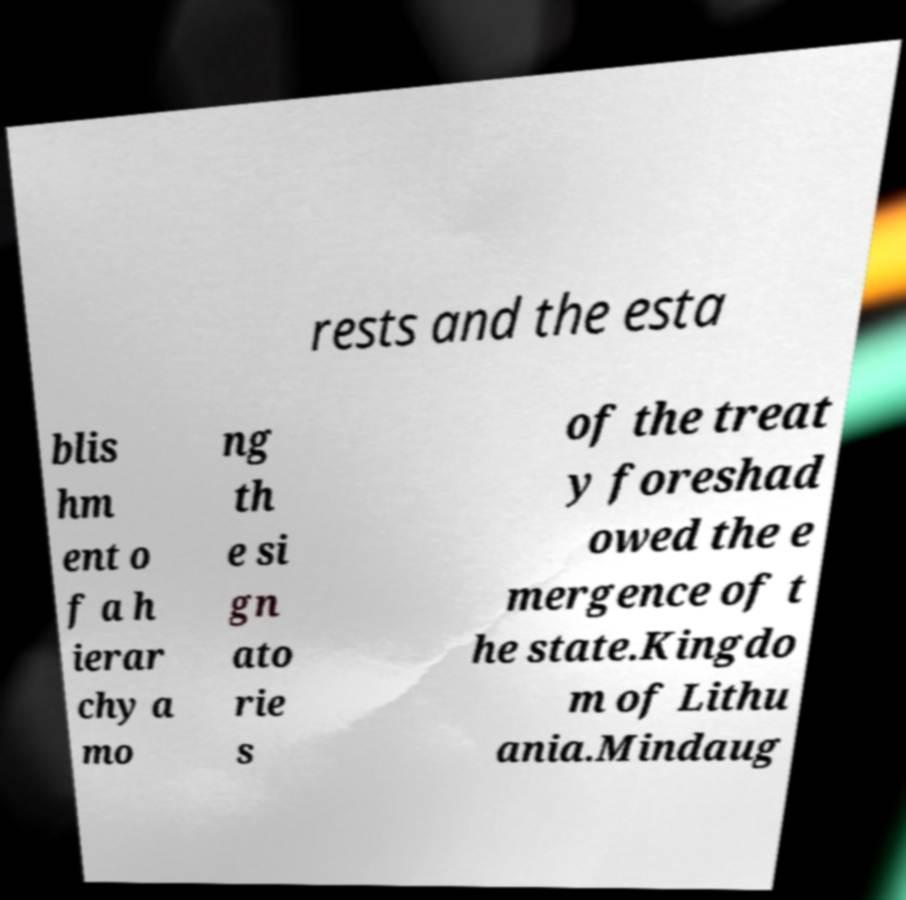What messages or text are displayed in this image? I need them in a readable, typed format. rests and the esta blis hm ent o f a h ierar chy a mo ng th e si gn ato rie s of the treat y foreshad owed the e mergence of t he state.Kingdo m of Lithu ania.Mindaug 